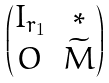Convert formula to latex. <formula><loc_0><loc_0><loc_500><loc_500>\begin{pmatrix} I _ { r _ { 1 } } & * \\ O & \widetilde { M } \end{pmatrix}</formula> 